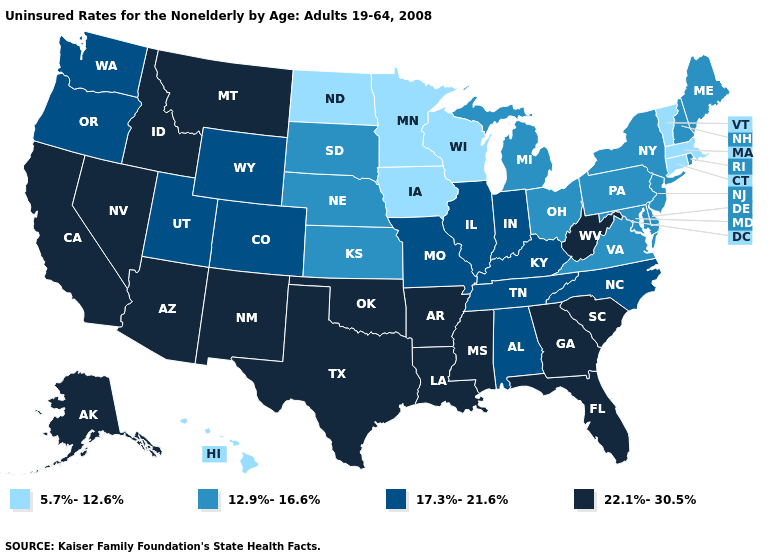Which states have the highest value in the USA?
Short answer required. Alaska, Arizona, Arkansas, California, Florida, Georgia, Idaho, Louisiana, Mississippi, Montana, Nevada, New Mexico, Oklahoma, South Carolina, Texas, West Virginia. Does Hawaii have the lowest value in the USA?
Quick response, please. Yes. Which states hav the highest value in the West?
Concise answer only. Alaska, Arizona, California, Idaho, Montana, Nevada, New Mexico. Among the states that border New Hampshire , which have the highest value?
Give a very brief answer. Maine. Does Vermont have the lowest value in the Northeast?
Concise answer only. Yes. Does Indiana have a higher value than Illinois?
Give a very brief answer. No. Name the states that have a value in the range 12.9%-16.6%?
Keep it brief. Delaware, Kansas, Maine, Maryland, Michigan, Nebraska, New Hampshire, New Jersey, New York, Ohio, Pennsylvania, Rhode Island, South Dakota, Virginia. Among the states that border Virginia , does West Virginia have the highest value?
Answer briefly. Yes. Among the states that border Tennessee , does Virginia have the lowest value?
Write a very short answer. Yes. Name the states that have a value in the range 22.1%-30.5%?
Answer briefly. Alaska, Arizona, Arkansas, California, Florida, Georgia, Idaho, Louisiana, Mississippi, Montana, Nevada, New Mexico, Oklahoma, South Carolina, Texas, West Virginia. Which states have the lowest value in the USA?
Write a very short answer. Connecticut, Hawaii, Iowa, Massachusetts, Minnesota, North Dakota, Vermont, Wisconsin. Does the first symbol in the legend represent the smallest category?
Concise answer only. Yes. Does South Dakota have the highest value in the MidWest?
Answer briefly. No. Which states have the highest value in the USA?
Keep it brief. Alaska, Arizona, Arkansas, California, Florida, Georgia, Idaho, Louisiana, Mississippi, Montana, Nevada, New Mexico, Oklahoma, South Carolina, Texas, West Virginia. Name the states that have a value in the range 22.1%-30.5%?
Concise answer only. Alaska, Arizona, Arkansas, California, Florida, Georgia, Idaho, Louisiana, Mississippi, Montana, Nevada, New Mexico, Oklahoma, South Carolina, Texas, West Virginia. 